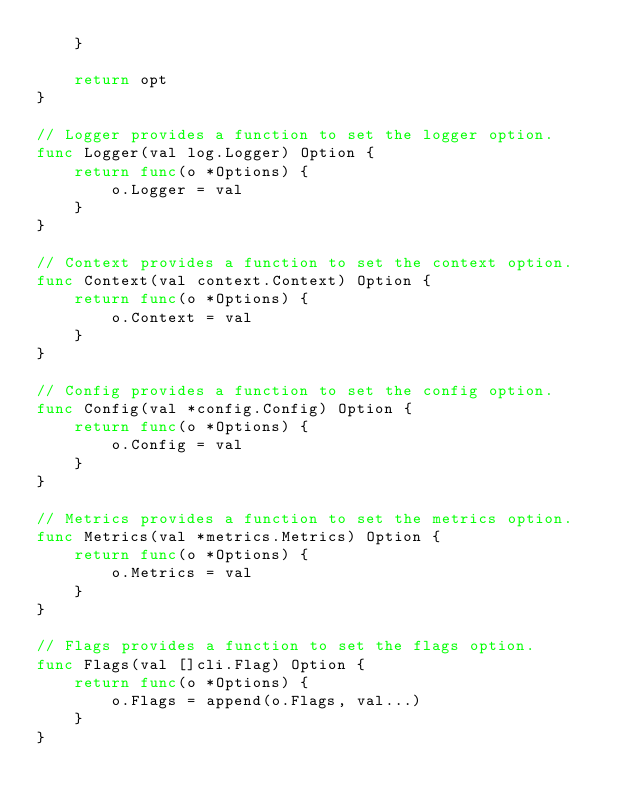Convert code to text. <code><loc_0><loc_0><loc_500><loc_500><_Go_>	}

	return opt
}

// Logger provides a function to set the logger option.
func Logger(val log.Logger) Option {
	return func(o *Options) {
		o.Logger = val
	}
}

// Context provides a function to set the context option.
func Context(val context.Context) Option {
	return func(o *Options) {
		o.Context = val
	}
}

// Config provides a function to set the config option.
func Config(val *config.Config) Option {
	return func(o *Options) {
		o.Config = val
	}
}

// Metrics provides a function to set the metrics option.
func Metrics(val *metrics.Metrics) Option {
	return func(o *Options) {
		o.Metrics = val
	}
}

// Flags provides a function to set the flags option.
func Flags(val []cli.Flag) Option {
	return func(o *Options) {
		o.Flags = append(o.Flags, val...)
	}
}
</code> 